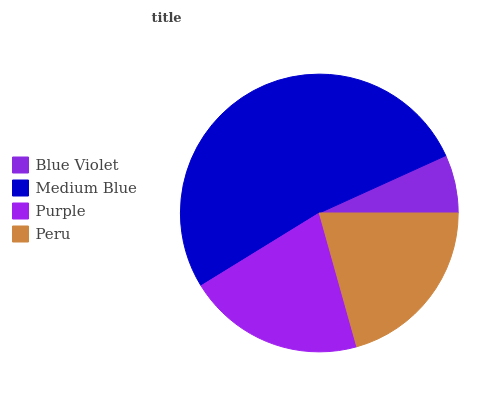Is Blue Violet the minimum?
Answer yes or no. Yes. Is Medium Blue the maximum?
Answer yes or no. Yes. Is Purple the minimum?
Answer yes or no. No. Is Purple the maximum?
Answer yes or no. No. Is Medium Blue greater than Purple?
Answer yes or no. Yes. Is Purple less than Medium Blue?
Answer yes or no. Yes. Is Purple greater than Medium Blue?
Answer yes or no. No. Is Medium Blue less than Purple?
Answer yes or no. No. Is Peru the high median?
Answer yes or no. Yes. Is Purple the low median?
Answer yes or no. Yes. Is Blue Violet the high median?
Answer yes or no. No. Is Medium Blue the low median?
Answer yes or no. No. 